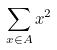<formula> <loc_0><loc_0><loc_500><loc_500>\sum _ { x \in A } x ^ { 2 }</formula> 